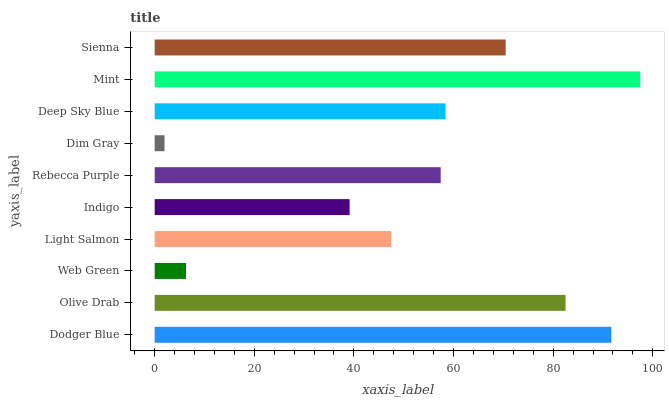Is Dim Gray the minimum?
Answer yes or no. Yes. Is Mint the maximum?
Answer yes or no. Yes. Is Olive Drab the minimum?
Answer yes or no. No. Is Olive Drab the maximum?
Answer yes or no. No. Is Dodger Blue greater than Olive Drab?
Answer yes or no. Yes. Is Olive Drab less than Dodger Blue?
Answer yes or no. Yes. Is Olive Drab greater than Dodger Blue?
Answer yes or no. No. Is Dodger Blue less than Olive Drab?
Answer yes or no. No. Is Deep Sky Blue the high median?
Answer yes or no. Yes. Is Rebecca Purple the low median?
Answer yes or no. Yes. Is Dim Gray the high median?
Answer yes or no. No. Is Deep Sky Blue the low median?
Answer yes or no. No. 